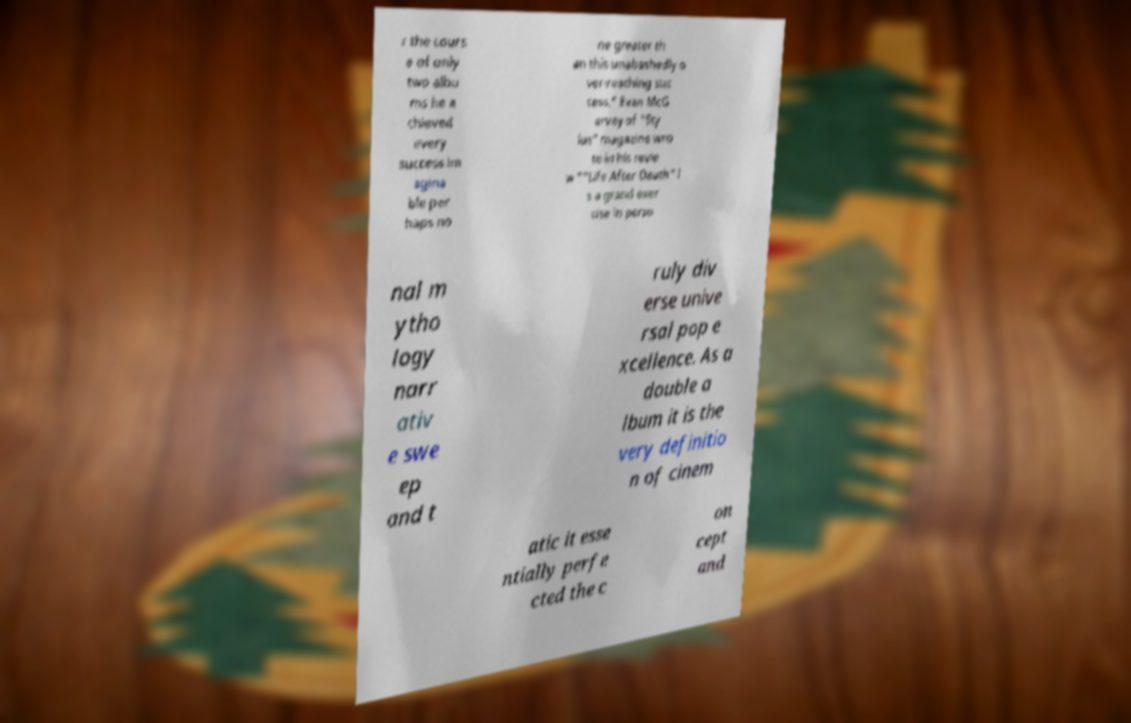I need the written content from this picture converted into text. Can you do that? r the cours e of only two albu ms he a chieved every success im agina ble per haps no ne greater th an this unabashedly o ver-reaching suc cess." Evan McG arvey of "Sty lus" magazine wro te in his revie w ""Life After Death" i s a grand exer cise in perso nal m ytho logy narr ativ e swe ep and t ruly div erse unive rsal pop e xcellence. As a double a lbum it is the very definitio n of cinem atic it esse ntially perfe cted the c on cept and 